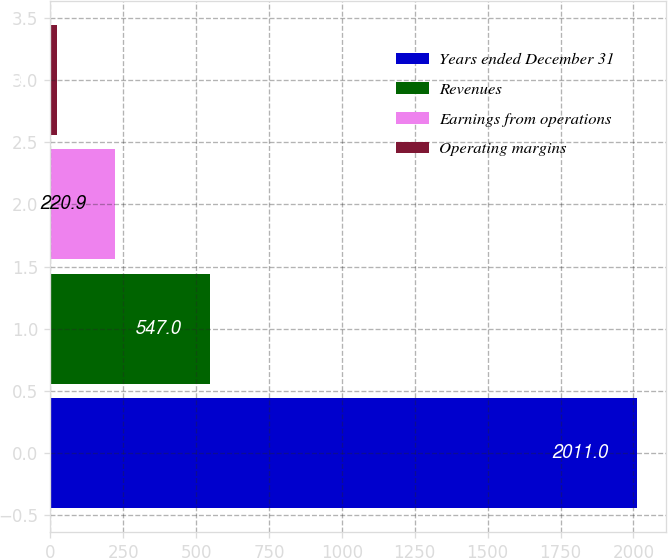<chart> <loc_0><loc_0><loc_500><loc_500><bar_chart><fcel>Years ended December 31<fcel>Revenues<fcel>Earnings from operations<fcel>Operating margins<nl><fcel>2011<fcel>547<fcel>220.9<fcel>22<nl></chart> 